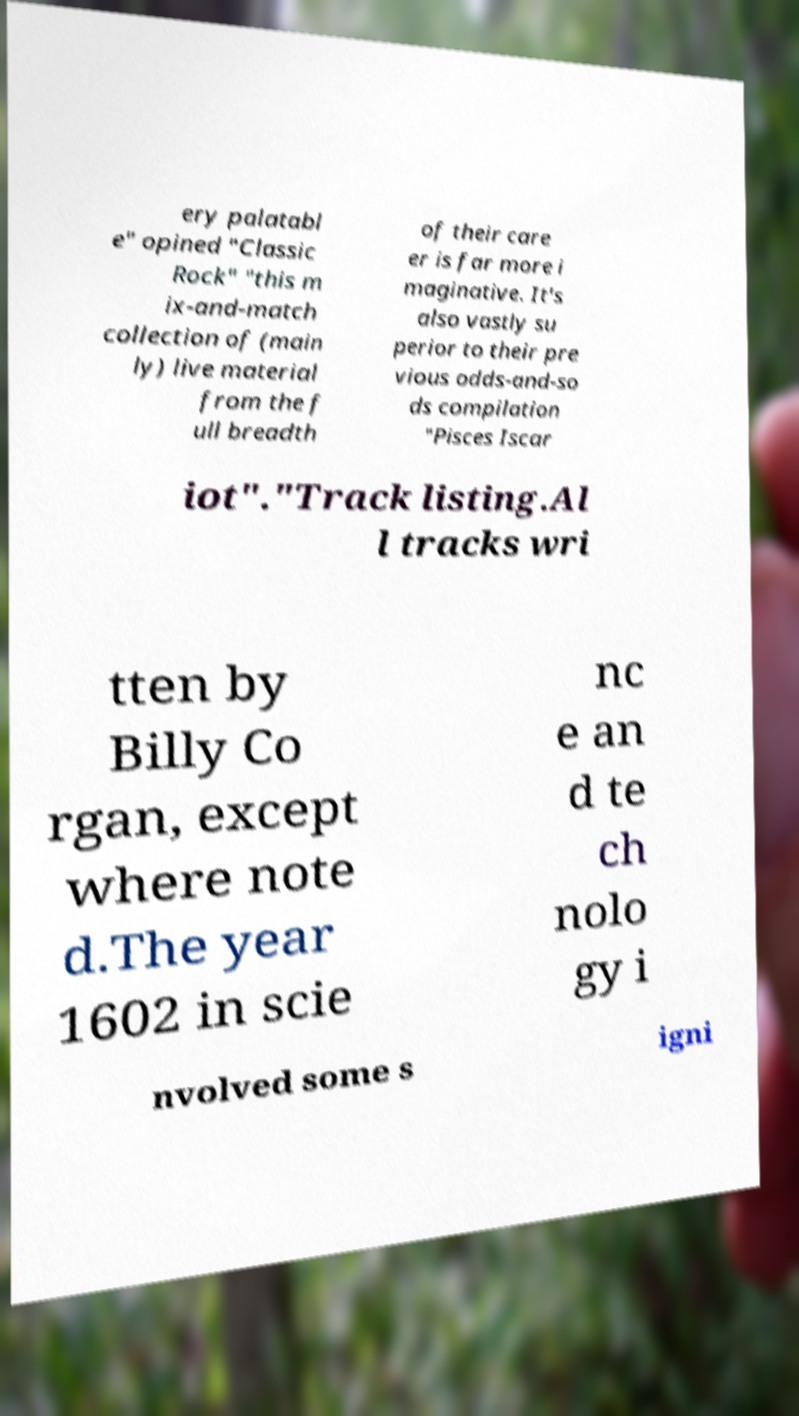Please read and relay the text visible in this image. What does it say? ery palatabl e" opined "Classic Rock" "this m ix-and-match collection of (main ly) live material from the f ull breadth of their care er is far more i maginative. It's also vastly su perior to their pre vious odds-and-so ds compilation "Pisces Iscar iot"."Track listing.Al l tracks wri tten by Billy Co rgan, except where note d.The year 1602 in scie nc e an d te ch nolo gy i nvolved some s igni 